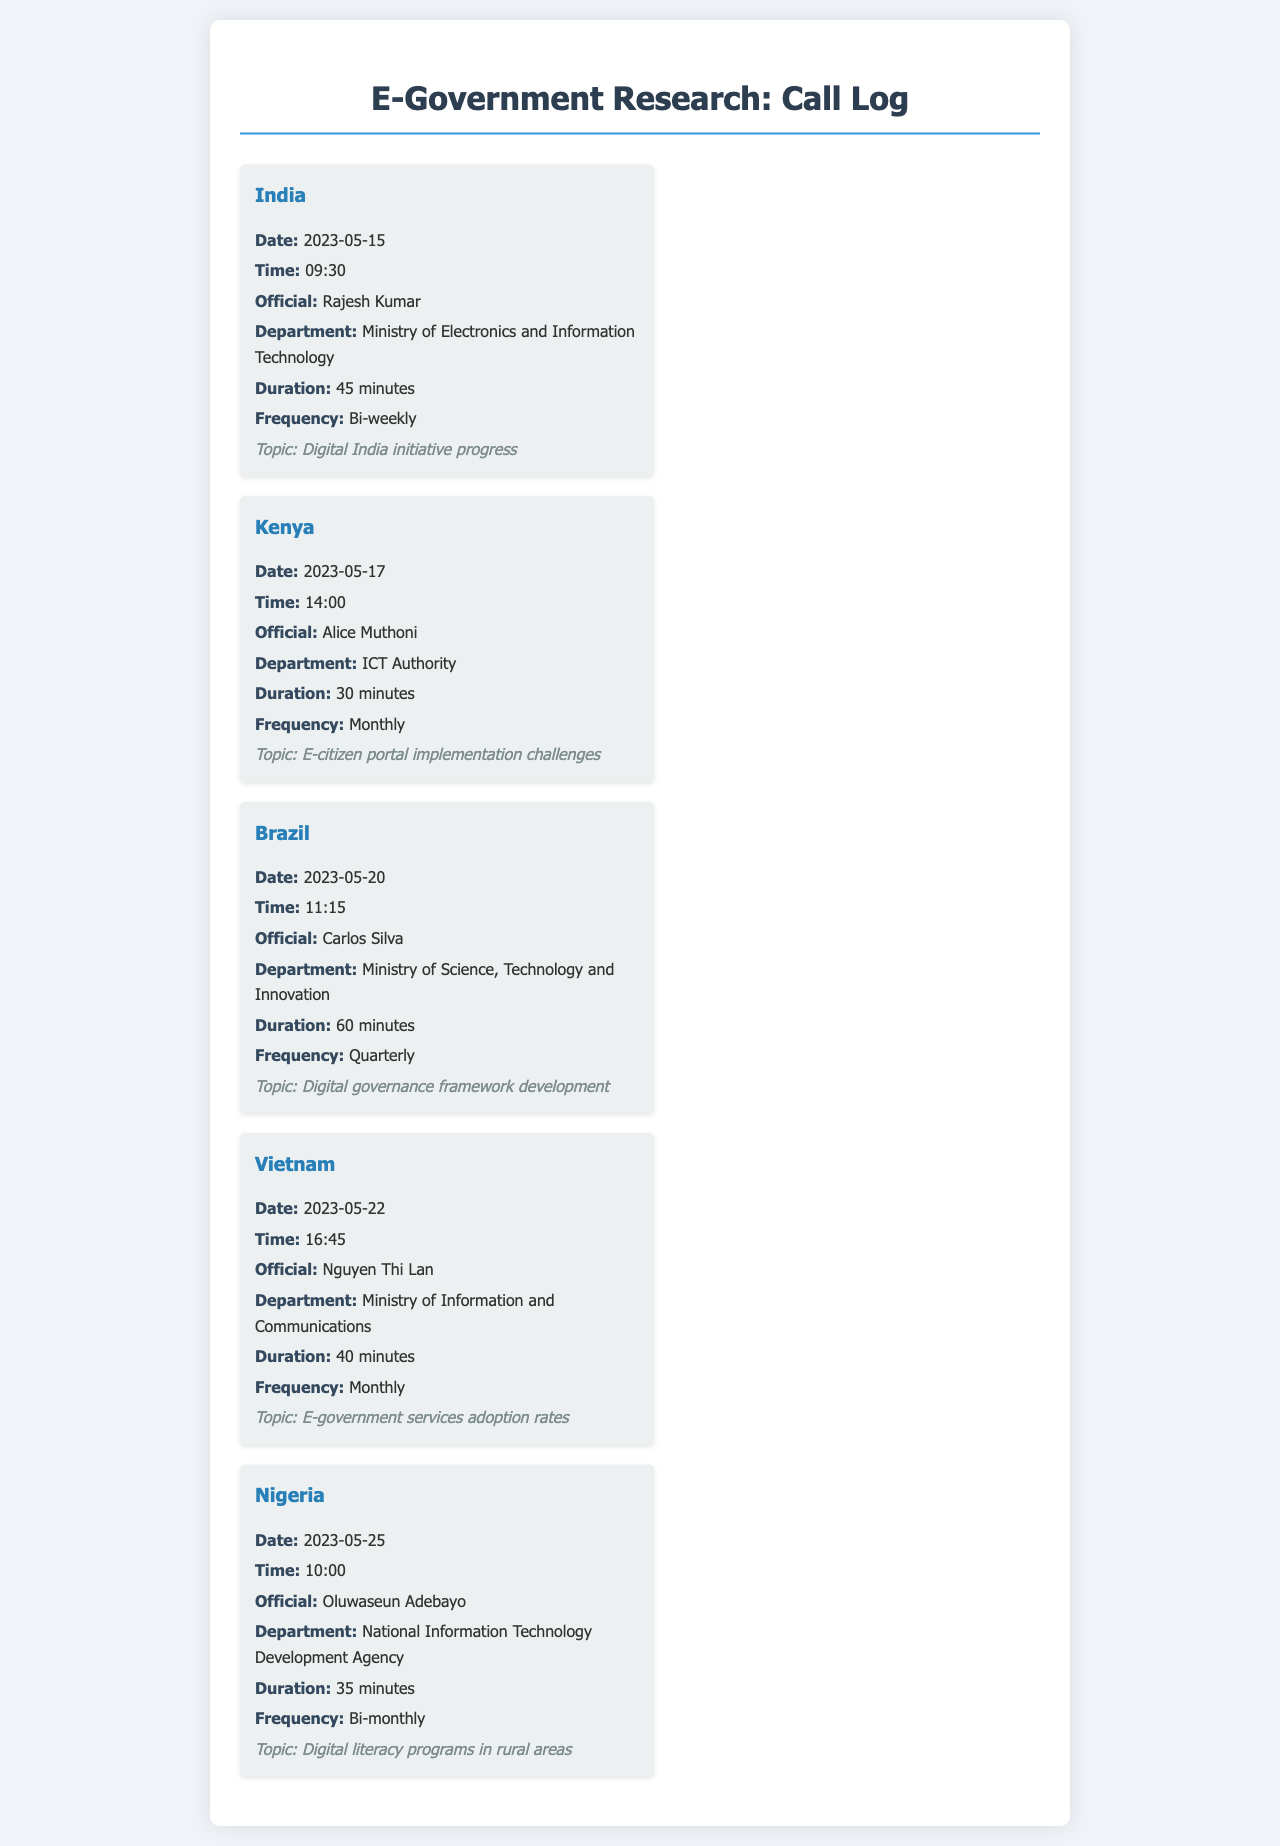What is the frequency of calls with Rajesh Kumar? The frequency for calls with Rajesh Kumar is bi-weekly, as mentioned in the entry.
Answer: Bi-weekly What was the duration of the call with Alice Muthoni? The duration of the call with Alice Muthoni is given as 30 minutes in the document.
Answer: 30 minutes Which country had a call discussing digital governance framework development? The call discussing digital governance framework development took place with Brazil, as indicated in the call entry.
Answer: Brazil When did the call with Oluwaseun Adebayo occur? The date of the call with Oluwaseun Adebayo is specified as 2023-05-25 in the entry.
Answer: 2023-05-25 How often does the call with Nguyen Thi Lan occur? The frequency of the call with Nguyen Thi Lan is monthly, as stated in the document.
Answer: Monthly What department is Rajesh Kumar associated with? Rajesh Kumar is associated with the Ministry of Electronics and Information Technology, as noted in the call log.
Answer: Ministry of Electronics and Information Technology Which official discussed e-citizen portal implementation challenges? The official who discussed e-citizen portal implementation challenges is Alice Muthoni.
Answer: Alice Muthoni How long was the longest call in the log? The longest call in the log was 60 minutes, as mentioned in the entry for Brazil.
Answer: 60 minutes 